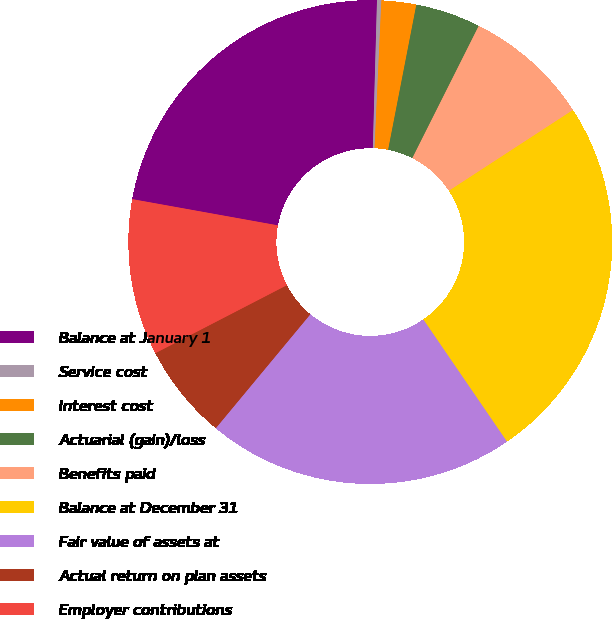<chart> <loc_0><loc_0><loc_500><loc_500><pie_chart><fcel>Balance at January 1<fcel>Service cost<fcel>Interest cost<fcel>Actuarial (gain)/loss<fcel>Benefits paid<fcel>Balance at December 31<fcel>Fair value of assets at<fcel>Actual return on plan assets<fcel>Employer contributions<nl><fcel>22.61%<fcel>0.29%<fcel>2.32%<fcel>4.35%<fcel>8.41%<fcel>24.63%<fcel>20.58%<fcel>6.38%<fcel>10.43%<nl></chart> 